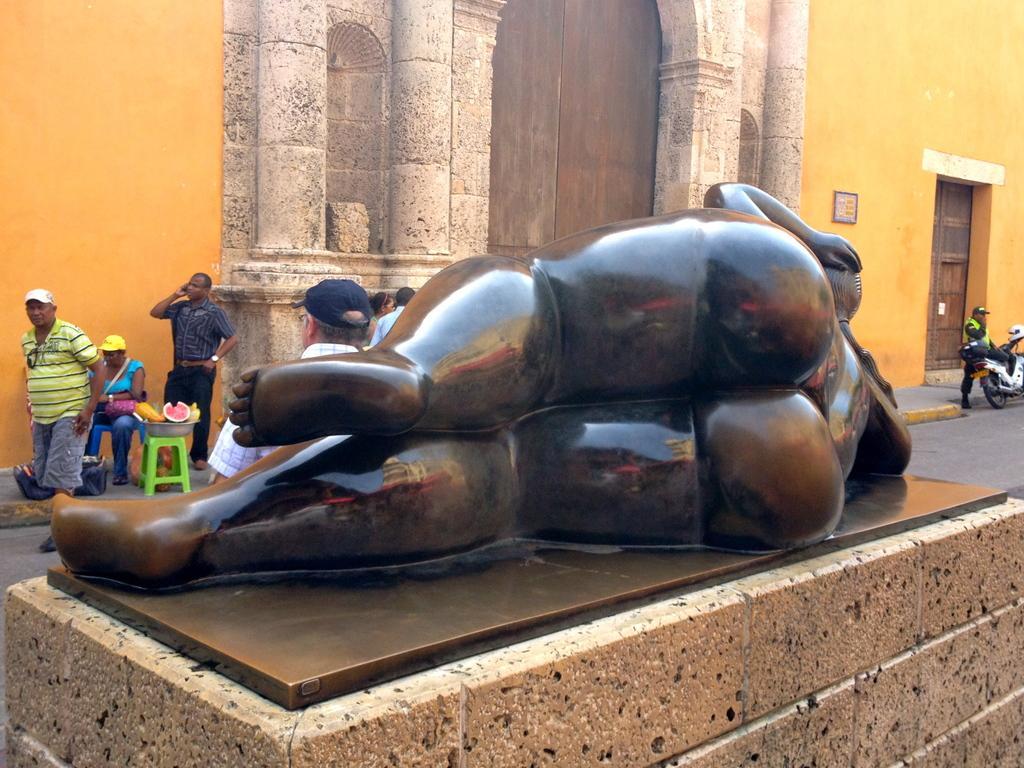Please provide a concise description of this image. In the center of the image, we can see a statue and in the background, there are people and some of them are wearing caps and there are fruits in the container, which is placed on the stool and we can see some other objects and there is a wall, frame and we can see doors and there is a person on the bike. At the bottom, there is a road. 